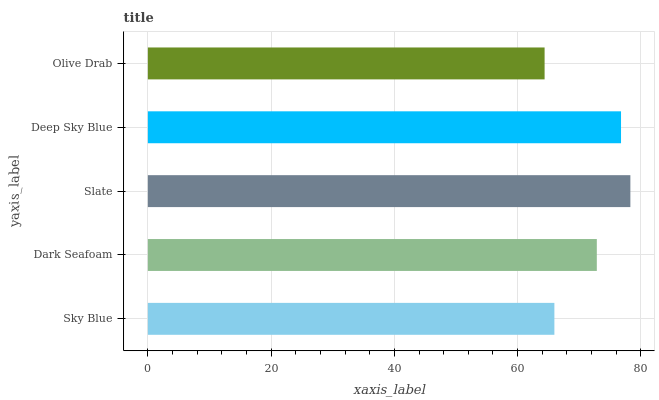Is Olive Drab the minimum?
Answer yes or no. Yes. Is Slate the maximum?
Answer yes or no. Yes. Is Dark Seafoam the minimum?
Answer yes or no. No. Is Dark Seafoam the maximum?
Answer yes or no. No. Is Dark Seafoam greater than Sky Blue?
Answer yes or no. Yes. Is Sky Blue less than Dark Seafoam?
Answer yes or no. Yes. Is Sky Blue greater than Dark Seafoam?
Answer yes or no. No. Is Dark Seafoam less than Sky Blue?
Answer yes or no. No. Is Dark Seafoam the high median?
Answer yes or no. Yes. Is Dark Seafoam the low median?
Answer yes or no. Yes. Is Deep Sky Blue the high median?
Answer yes or no. No. Is Sky Blue the low median?
Answer yes or no. No. 